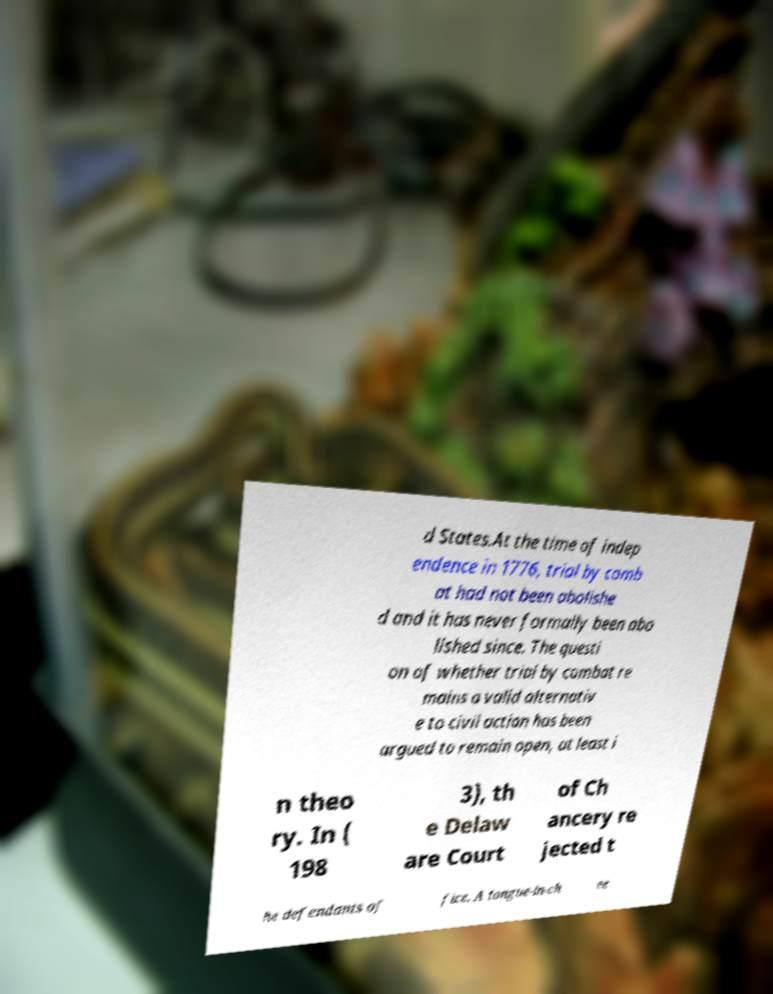Please read and relay the text visible in this image. What does it say? d States.At the time of indep endence in 1776, trial by comb at had not been abolishe d and it has never formally been abo lished since. The questi on of whether trial by combat re mains a valid alternativ e to civil action has been argued to remain open, at least i n theo ry. In ( 198 3), th e Delaw are Court of Ch ancery re jected t he defendants of fice. A tongue-in-ch ee 